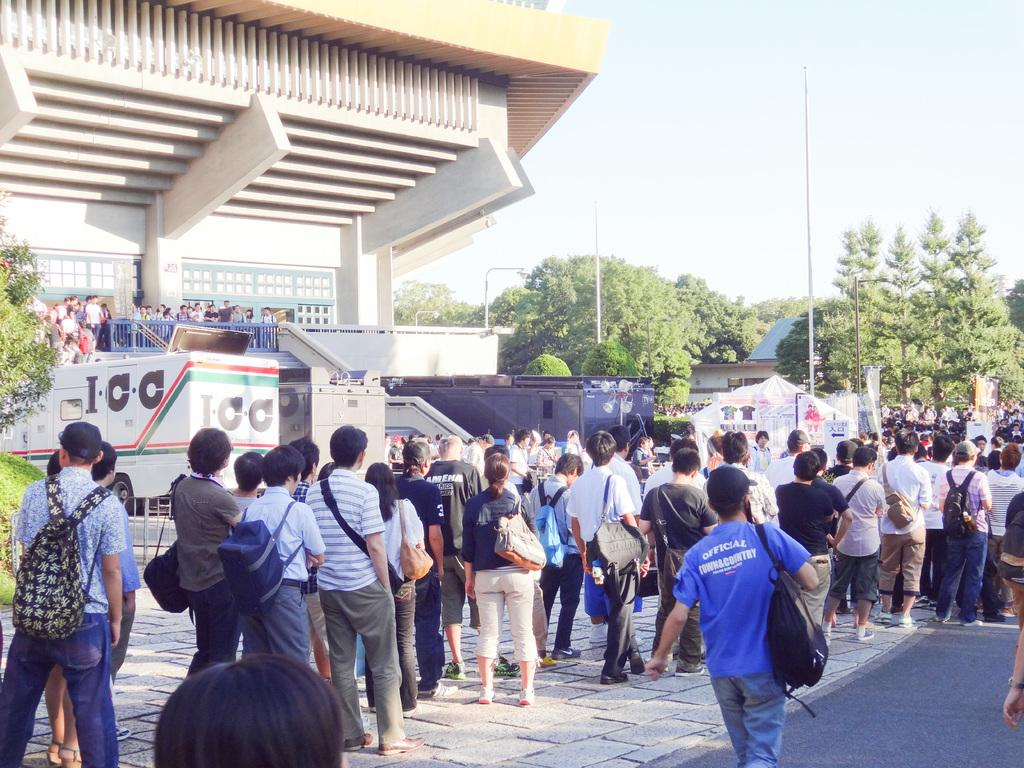What is the main focus of the image? The main focus of the image is the people in the center. What can be seen in the background of the image? In the background, there are posters, trees, poles, buildings, vehicles, and a stall. Can you describe the surroundings of the people in the image? The people are surrounded by various elements in the background, including posters, trees, poles, buildings, vehicles, and a stall. What type of board is being used by the people in the image? There is no board visible in the image. Can you tell me how many engines are present in the image? There are no engines present in the image. 